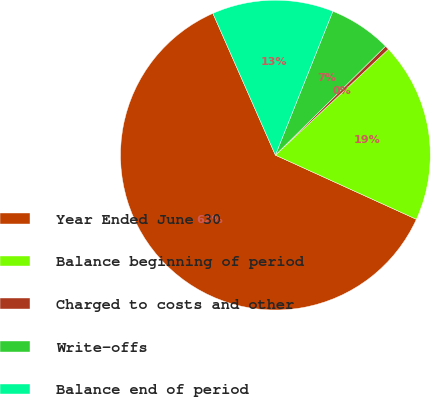<chart> <loc_0><loc_0><loc_500><loc_500><pie_chart><fcel>Year Ended June 30<fcel>Balance beginning of period<fcel>Charged to costs and other<fcel>Write-offs<fcel>Balance end of period<nl><fcel>61.59%<fcel>18.78%<fcel>0.43%<fcel>6.54%<fcel>12.66%<nl></chart> 